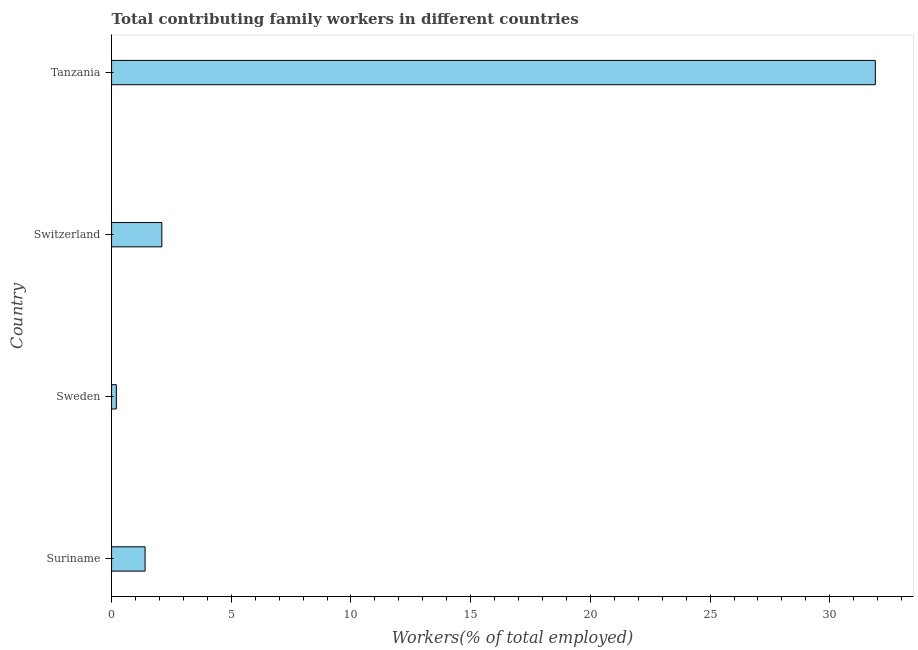Does the graph contain any zero values?
Your answer should be very brief. No. What is the title of the graph?
Ensure brevity in your answer.  Total contributing family workers in different countries. What is the label or title of the X-axis?
Provide a succinct answer. Workers(% of total employed). What is the contributing family workers in Switzerland?
Make the answer very short. 2.1. Across all countries, what is the maximum contributing family workers?
Give a very brief answer. 31.9. Across all countries, what is the minimum contributing family workers?
Provide a short and direct response. 0.2. In which country was the contributing family workers maximum?
Keep it short and to the point. Tanzania. What is the sum of the contributing family workers?
Keep it short and to the point. 35.6. What is the difference between the contributing family workers in Suriname and Switzerland?
Provide a succinct answer. -0.7. What is the median contributing family workers?
Ensure brevity in your answer.  1.75. What is the ratio of the contributing family workers in Suriname to that in Tanzania?
Your response must be concise. 0.04. Is the contributing family workers in Suriname less than that in Switzerland?
Make the answer very short. Yes. Is the difference between the contributing family workers in Suriname and Switzerland greater than the difference between any two countries?
Offer a very short reply. No. What is the difference between the highest and the second highest contributing family workers?
Ensure brevity in your answer.  29.8. Is the sum of the contributing family workers in Sweden and Switzerland greater than the maximum contributing family workers across all countries?
Your answer should be very brief. No. What is the difference between the highest and the lowest contributing family workers?
Offer a very short reply. 31.7. In how many countries, is the contributing family workers greater than the average contributing family workers taken over all countries?
Give a very brief answer. 1. How many countries are there in the graph?
Keep it short and to the point. 4. What is the Workers(% of total employed) in Suriname?
Give a very brief answer. 1.4. What is the Workers(% of total employed) in Sweden?
Offer a very short reply. 0.2. What is the Workers(% of total employed) of Switzerland?
Offer a terse response. 2.1. What is the Workers(% of total employed) of Tanzania?
Your answer should be very brief. 31.9. What is the difference between the Workers(% of total employed) in Suriname and Switzerland?
Ensure brevity in your answer.  -0.7. What is the difference between the Workers(% of total employed) in Suriname and Tanzania?
Your answer should be very brief. -30.5. What is the difference between the Workers(% of total employed) in Sweden and Switzerland?
Your answer should be very brief. -1.9. What is the difference between the Workers(% of total employed) in Sweden and Tanzania?
Your answer should be very brief. -31.7. What is the difference between the Workers(% of total employed) in Switzerland and Tanzania?
Make the answer very short. -29.8. What is the ratio of the Workers(% of total employed) in Suriname to that in Switzerland?
Make the answer very short. 0.67. What is the ratio of the Workers(% of total employed) in Suriname to that in Tanzania?
Your answer should be compact. 0.04. What is the ratio of the Workers(% of total employed) in Sweden to that in Switzerland?
Offer a very short reply. 0.1. What is the ratio of the Workers(% of total employed) in Sweden to that in Tanzania?
Your response must be concise. 0.01. What is the ratio of the Workers(% of total employed) in Switzerland to that in Tanzania?
Offer a terse response. 0.07. 